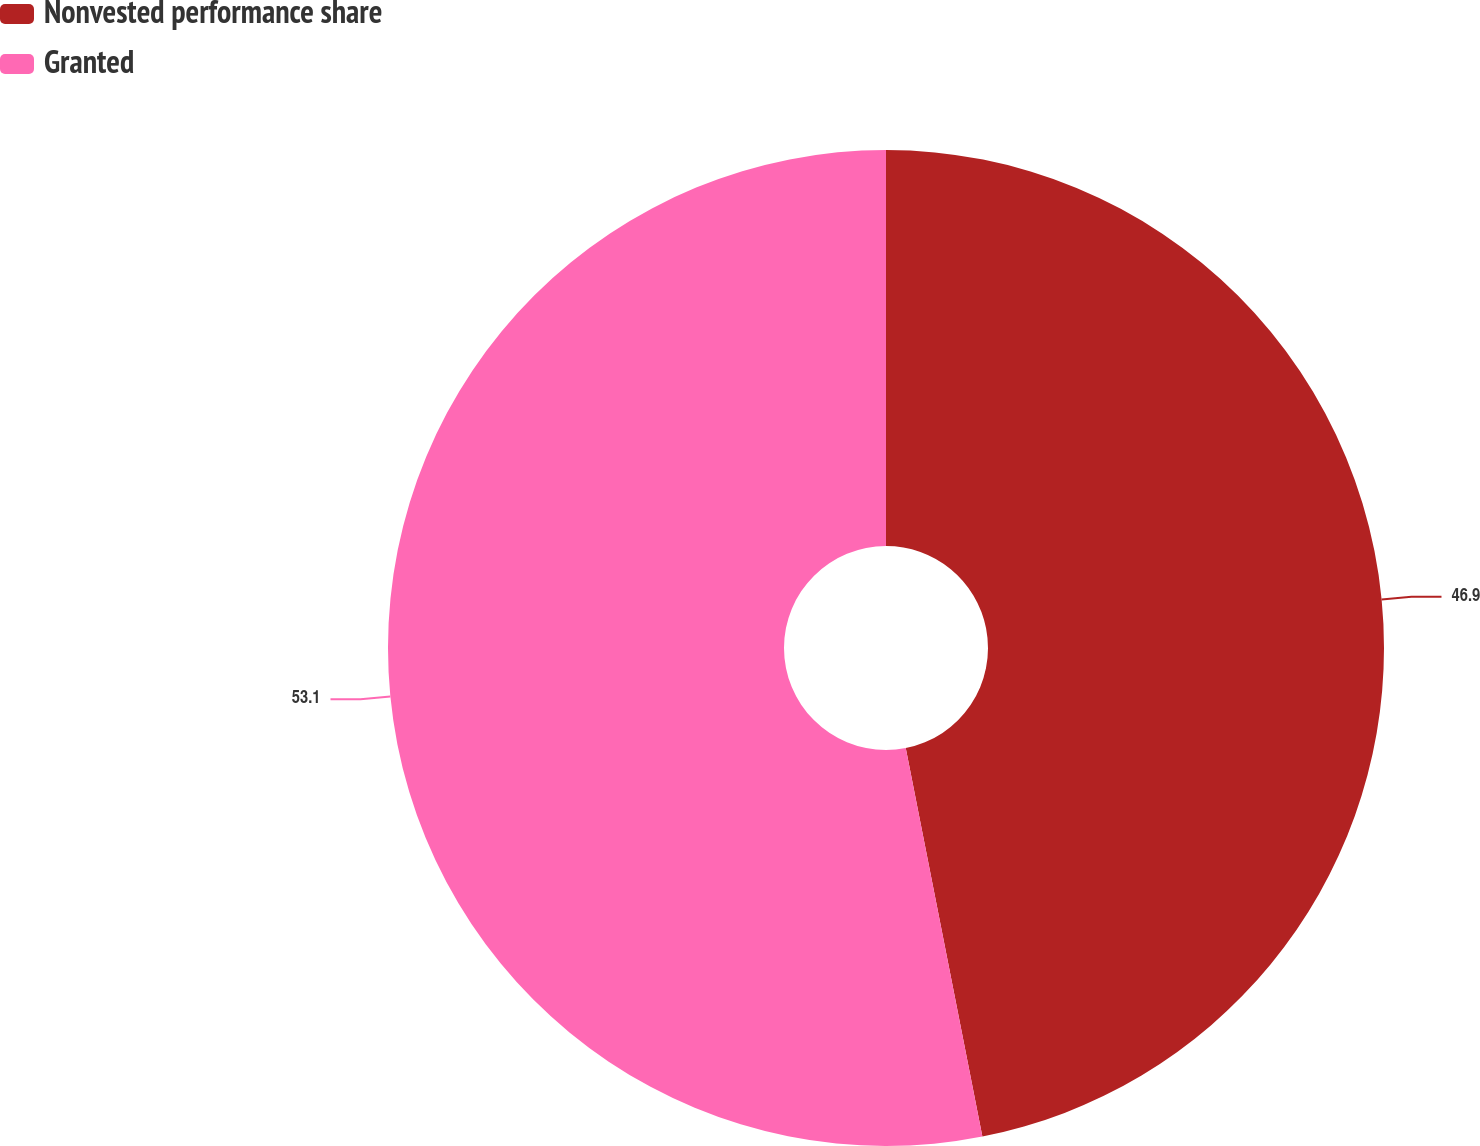Convert chart to OTSL. <chart><loc_0><loc_0><loc_500><loc_500><pie_chart><fcel>Nonvested performance share<fcel>Granted<nl><fcel>46.9%<fcel>53.1%<nl></chart> 